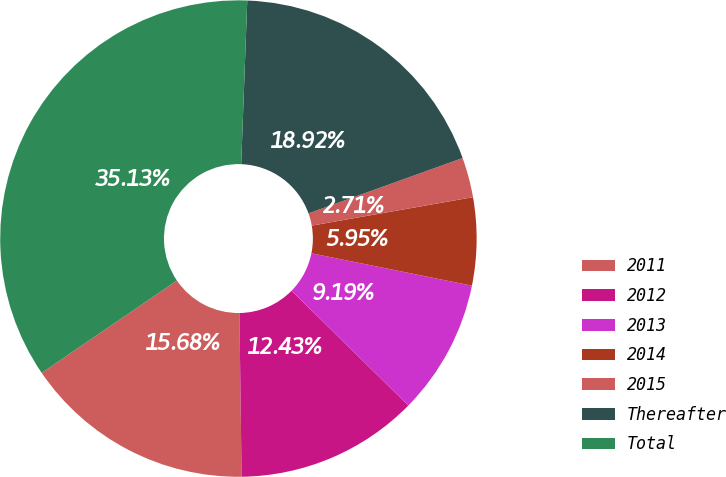<chart> <loc_0><loc_0><loc_500><loc_500><pie_chart><fcel>2011<fcel>2012<fcel>2013<fcel>2014<fcel>2015<fcel>Thereafter<fcel>Total<nl><fcel>15.68%<fcel>12.43%<fcel>9.19%<fcel>5.95%<fcel>2.71%<fcel>18.92%<fcel>35.13%<nl></chart> 